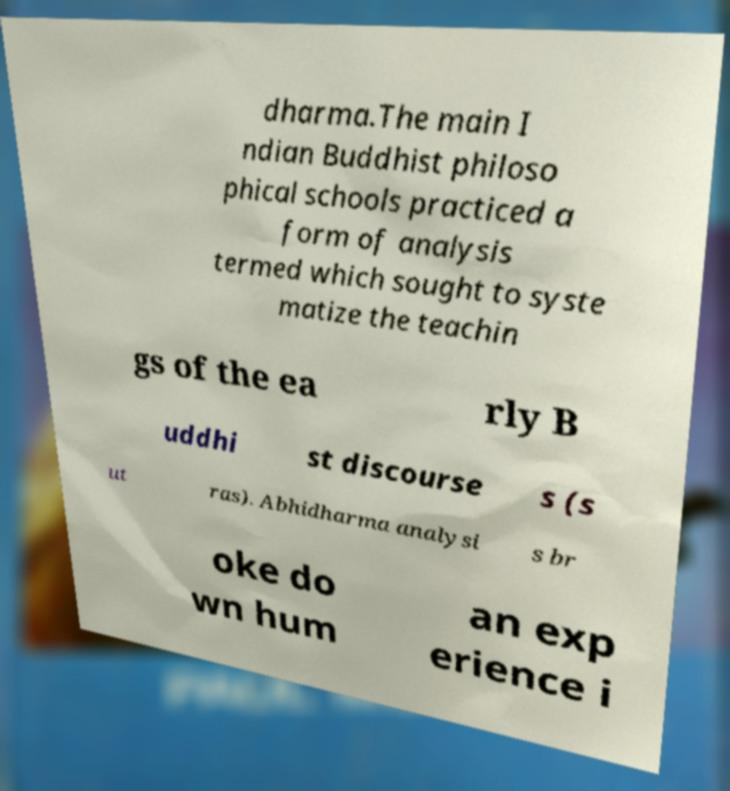There's text embedded in this image that I need extracted. Can you transcribe it verbatim? dharma.The main I ndian Buddhist philoso phical schools practiced a form of analysis termed which sought to syste matize the teachin gs of the ea rly B uddhi st discourse s (s ut ras). Abhidharma analysi s br oke do wn hum an exp erience i 